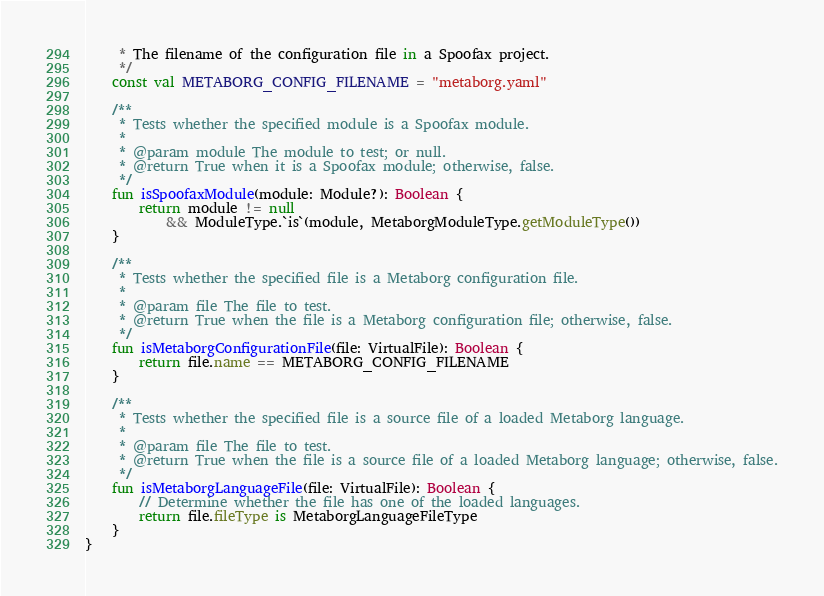Convert code to text. <code><loc_0><loc_0><loc_500><loc_500><_Kotlin_>     * The filename of the configuration file in a Spoofax project.
     */
    const val METABORG_CONFIG_FILENAME = "metaborg.yaml"

    /**
     * Tests whether the specified module is a Spoofax module.
     *
     * @param module The module to test; or null.
     * @return True when it is a Spoofax module; otherwise, false.
     */
    fun isSpoofaxModule(module: Module?): Boolean {
        return module != null
            && ModuleType.`is`(module, MetaborgModuleType.getModuleType())
    }

    /**
     * Tests whether the specified file is a Metaborg configuration file.
     *
     * @param file The file to test.
     * @return True when the file is a Metaborg configuration file; otherwise, false.
     */
    fun isMetaborgConfigurationFile(file: VirtualFile): Boolean {
        return file.name == METABORG_CONFIG_FILENAME
    }

    /**
     * Tests whether the specified file is a source file of a loaded Metaborg language.
     *
     * @param file The file to test.
     * @return True when the file is a source file of a loaded Metaborg language; otherwise, false.
     */
    fun isMetaborgLanguageFile(file: VirtualFile): Boolean {
        // Determine whether the file has one of the loaded languages.
        return file.fileType is MetaborgLanguageFileType
    }
}</code> 